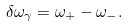Convert formula to latex. <formula><loc_0><loc_0><loc_500><loc_500>\delta \omega _ { \gamma } = \omega _ { + } - \omega _ { - } .</formula> 